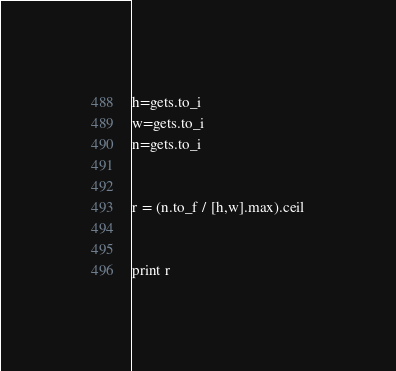<code> <loc_0><loc_0><loc_500><loc_500><_Ruby_>h=gets.to_i
w=gets.to_i
n=gets.to_i


r = (n.to_f / [h,w].max).ceil


print r
</code> 